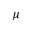<formula> <loc_0><loc_0><loc_500><loc_500>\mu</formula> 